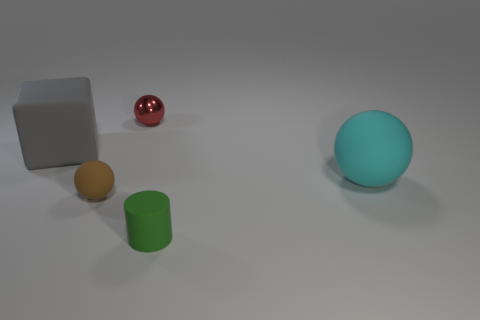Subtract 1 balls. How many balls are left? 2 Add 4 large gray rubber cubes. How many objects exist? 9 Subtract all cylinders. How many objects are left? 4 Add 2 big gray rubber objects. How many big gray rubber objects exist? 3 Subtract 1 red spheres. How many objects are left? 4 Subtract all cyan spheres. Subtract all big red metallic cylinders. How many objects are left? 4 Add 3 tiny rubber objects. How many tiny rubber objects are left? 5 